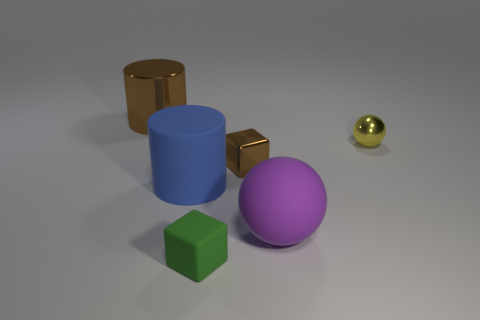Do the metallic object that is behind the yellow metallic ball and the tiny green thing have the same shape?
Provide a short and direct response. No. How many other things are the same shape as the purple object?
Provide a short and direct response. 1. What shape is the large matte thing that is behind the big purple rubber object?
Offer a very short reply. Cylinder. Are there any tiny brown objects made of the same material as the yellow sphere?
Your answer should be compact. Yes. Does the small block that is behind the matte sphere have the same color as the metal cylinder?
Your response must be concise. Yes. What is the size of the purple sphere?
Provide a succinct answer. Large. There is a ball that is in front of the cylinder in front of the brown metallic cylinder; are there any big purple matte things that are to the right of it?
Offer a very short reply. No. How many brown cubes are behind the brown shiny cylinder?
Your response must be concise. 0. What number of tiny shiny objects are the same color as the rubber block?
Your answer should be compact. 0. What number of objects are brown metal things to the left of the blue object or metal things that are on the left side of the green object?
Your answer should be very brief. 1. 